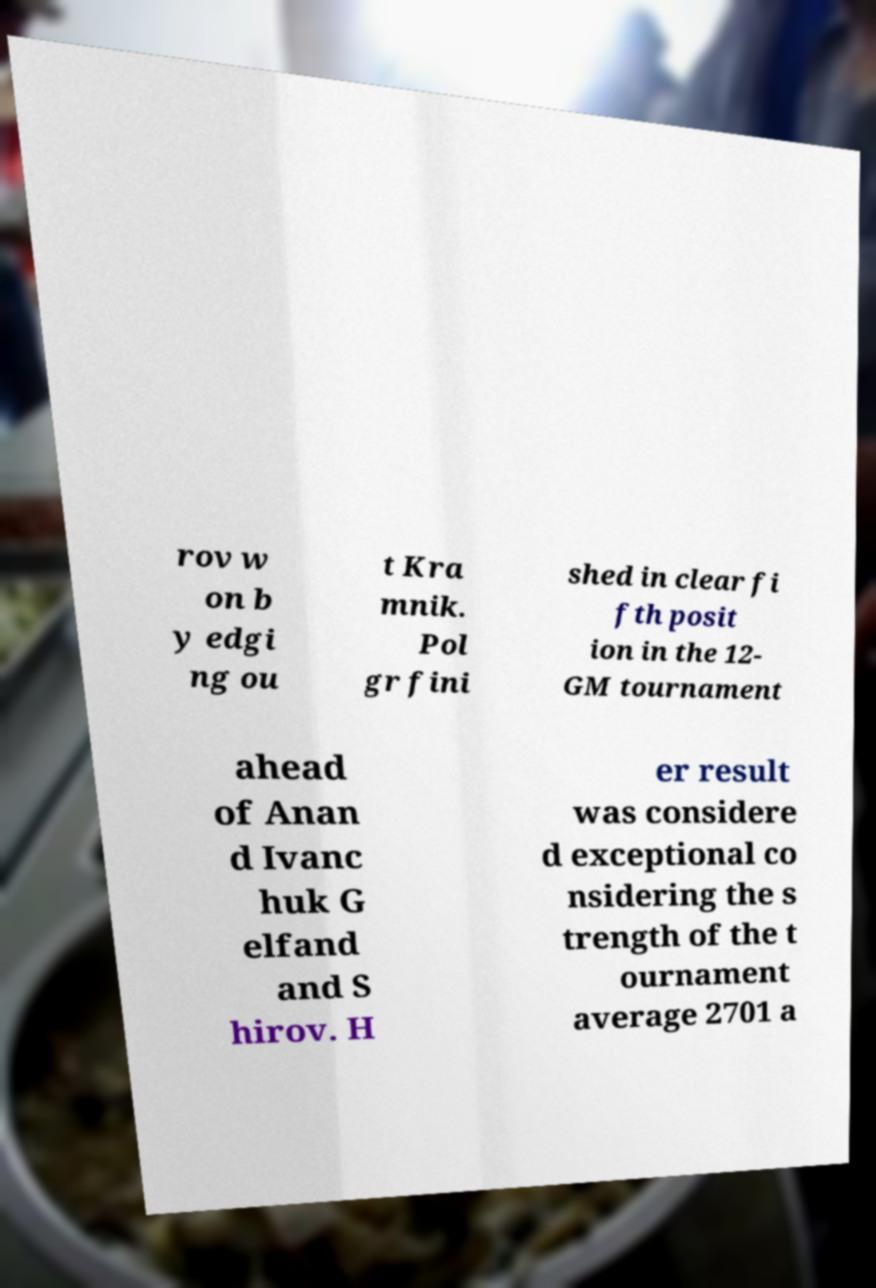For documentation purposes, I need the text within this image transcribed. Could you provide that? rov w on b y edgi ng ou t Kra mnik. Pol gr fini shed in clear fi fth posit ion in the 12- GM tournament ahead of Anan d Ivanc huk G elfand and S hirov. H er result was considere d exceptional co nsidering the s trength of the t ournament average 2701 a 